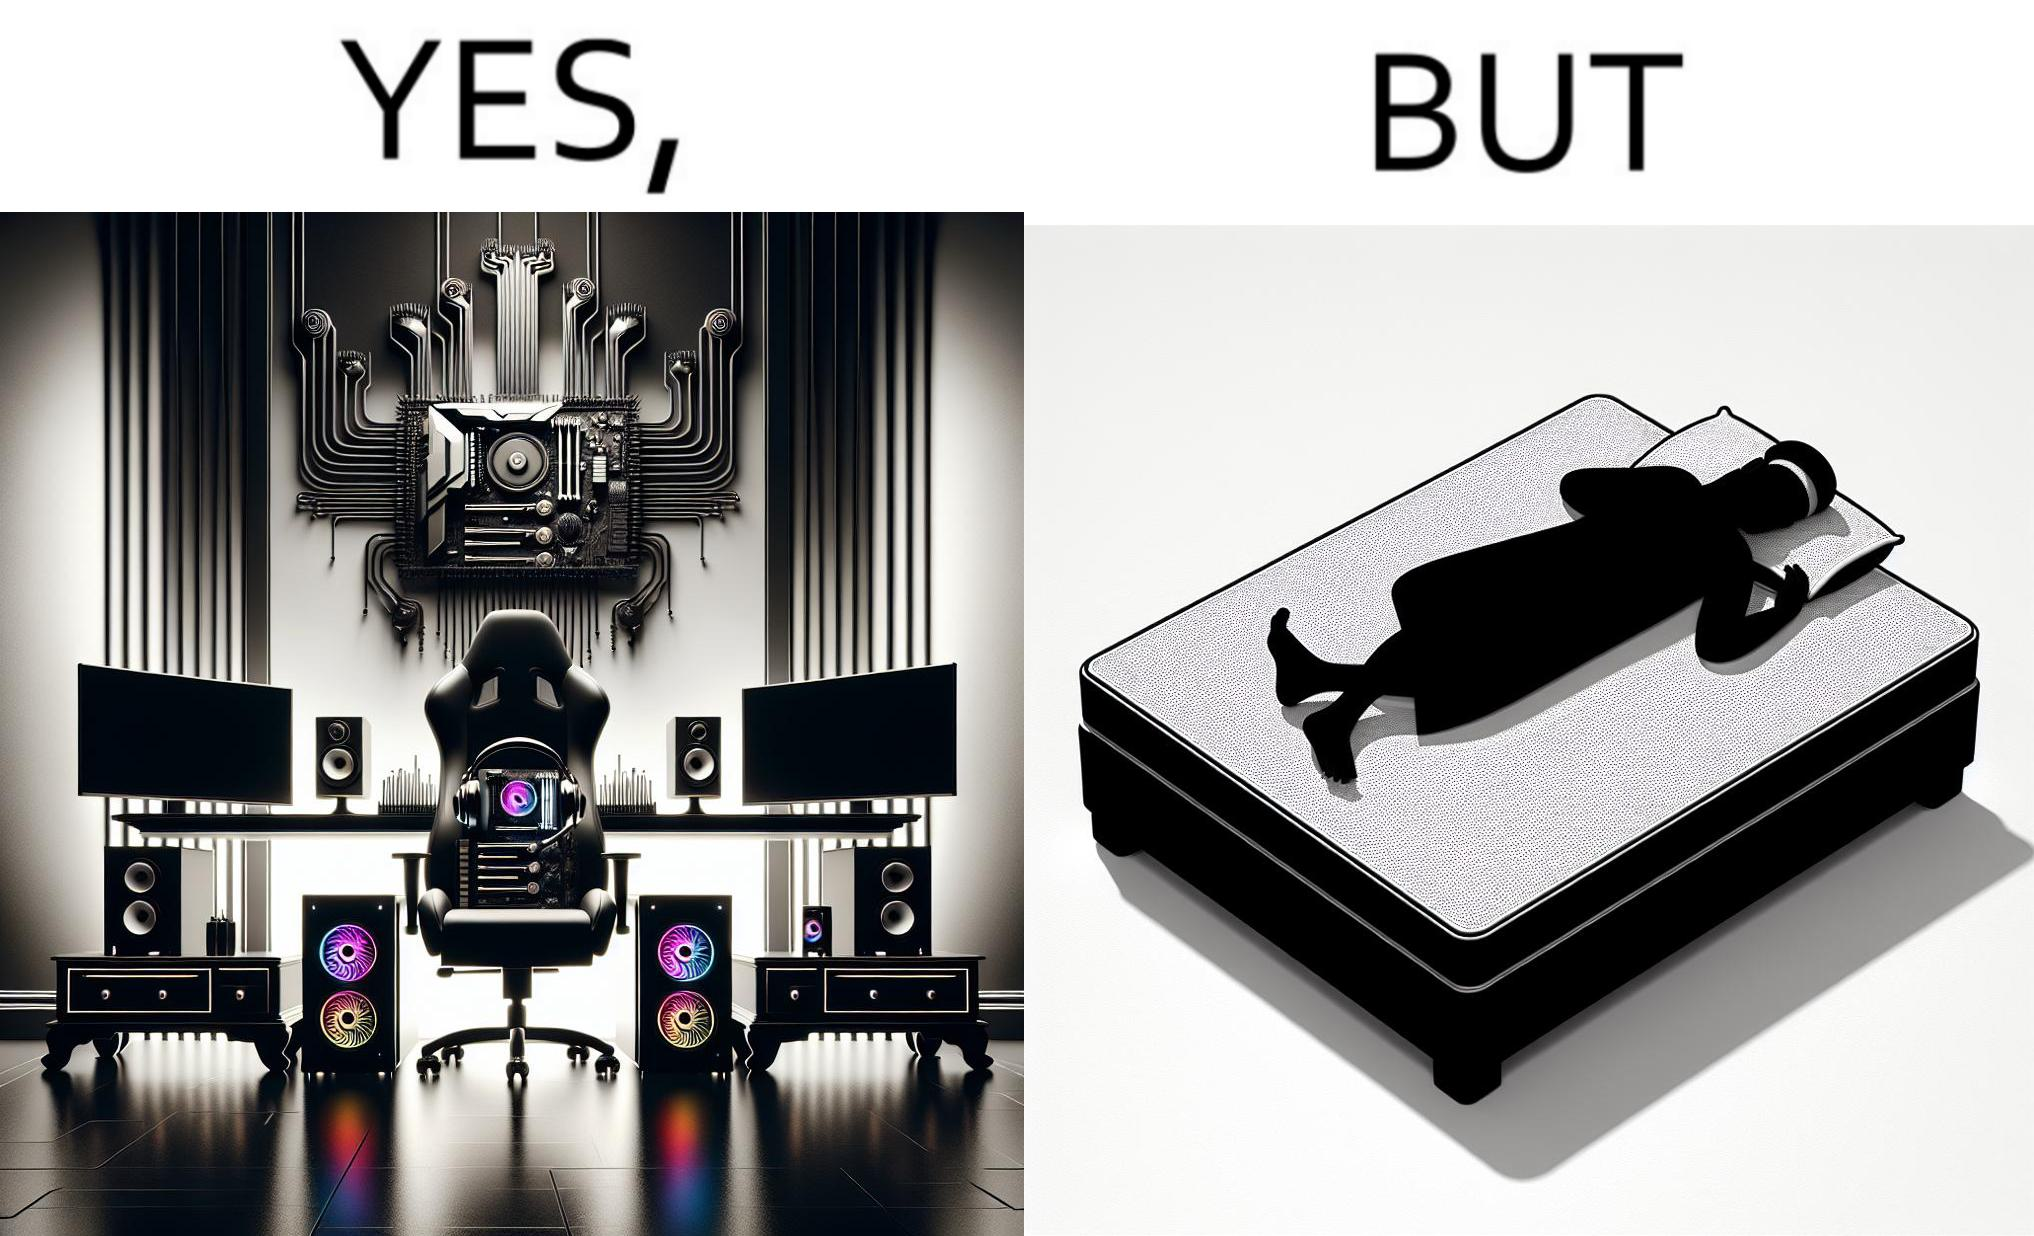Describe what you see in the left and right parts of this image. In the left part of the image: The image shows a computer desk with two monitors, two speakers on the side, a headphone hanging off the side of the table, a cpu on the floor with lights glowing on the front of the cpu and a very comfortable looking gaming chair. The whole setup looks high end and expensive. In the right part of the image: The image shows a man sleeping on a mattress on the floor. There does not seem to be a bedsheet on the mattress. 